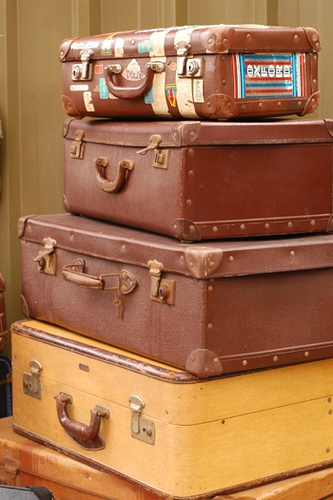Describe the objects in this image and their specific colors. I can see suitcase in tan, brown, and maroon tones, suitcase in tan, orange, and brown tones, suitcase in tan, maroon, brown, and salmon tones, suitcase in tan, ivory, brown, and maroon tones, and suitcase in tan, orange, brown, and salmon tones in this image. 